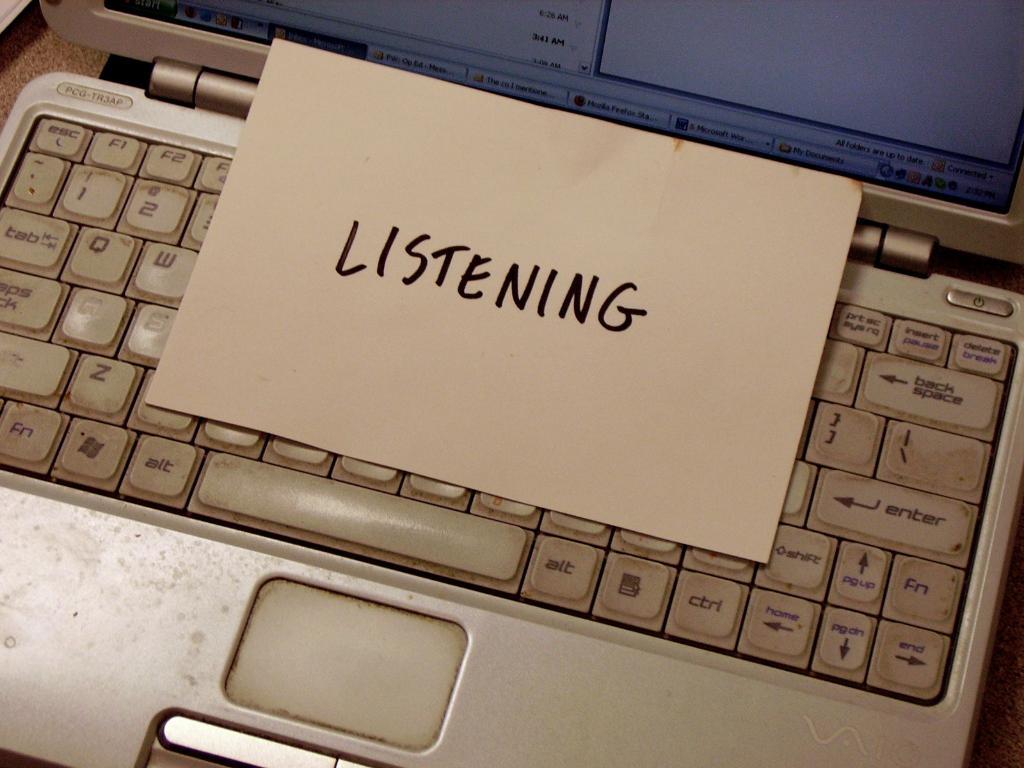What is on the paper?
Your answer should be compact. Listening. 